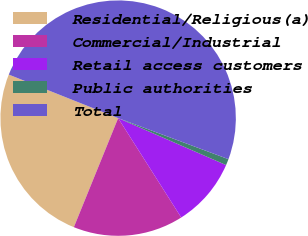Convert chart. <chart><loc_0><loc_0><loc_500><loc_500><pie_chart><fcel>Residential/Religious(a)<fcel>Commercial/Industrial<fcel>Retail access customers<fcel>Public authorities<fcel>Total<nl><fcel>24.89%<fcel>15.14%<fcel>9.47%<fcel>0.86%<fcel>49.64%<nl></chart> 